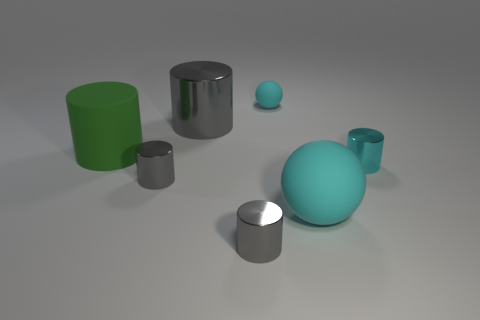What number of objects are big cyan spheres or big cyan things in front of the green matte thing?
Keep it short and to the point. 1. What shape is the cyan shiny object?
Provide a short and direct response. Cylinder. What shape is the large object in front of the small shiny object right of the big matte sphere?
Provide a succinct answer. Sphere. What material is the large object that is the same color as the tiny matte thing?
Offer a terse response. Rubber. There is another sphere that is the same material as the big ball; what is its color?
Your answer should be very brief. Cyan. Are there any other things that have the same size as the cyan metal cylinder?
Your response must be concise. Yes. There is a cylinder to the right of the small cyan matte object; does it have the same color as the large matte thing left of the tiny cyan sphere?
Give a very brief answer. No. Is the number of spheres that are left of the rubber cylinder greater than the number of metallic objects in front of the big cyan matte object?
Provide a short and direct response. No. There is a small matte object that is the same shape as the large cyan rubber thing; what is its color?
Make the answer very short. Cyan. Is there anything else that has the same shape as the tiny cyan shiny object?
Your answer should be very brief. Yes. 